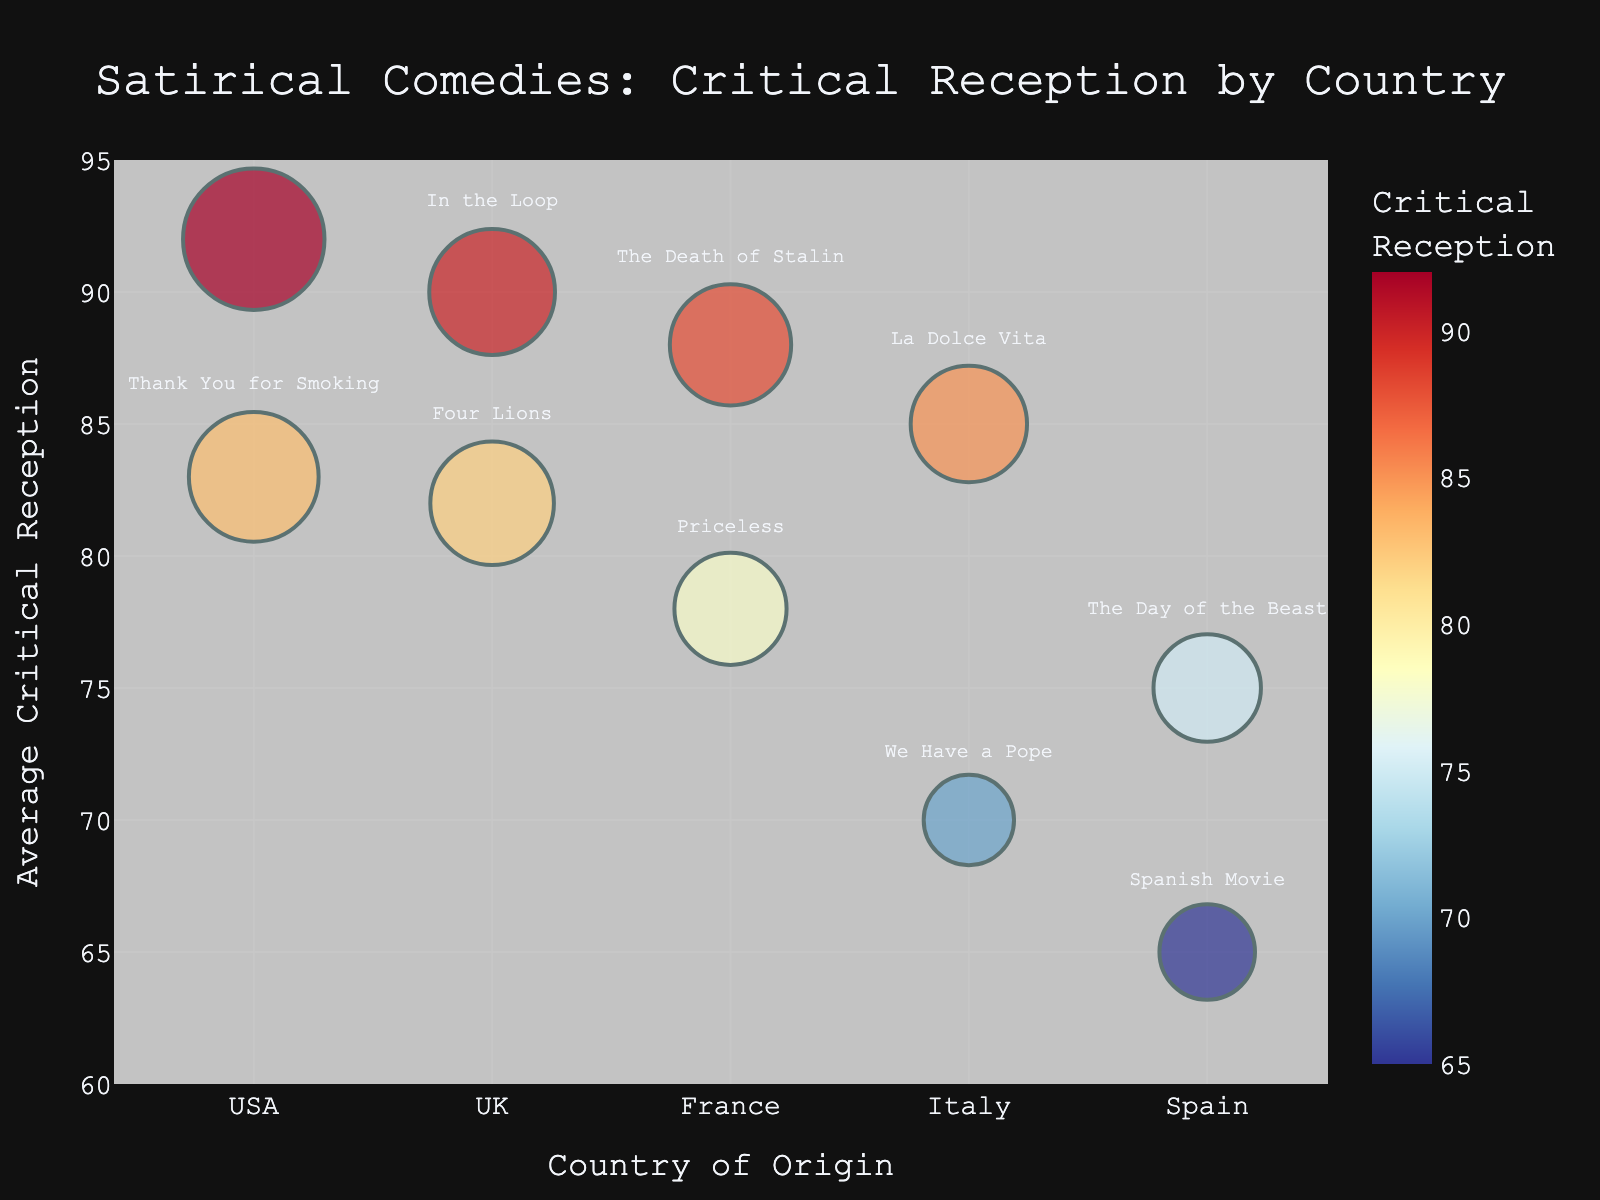Which country has the highest average critical reception for its satirical comedies? The highest average critical reception is indicated by the y-axis value. Dr. Strangelove from the USA has the highest average critical reception of 92.
Answer: USA Which film has the smallest bubble size? The bubble size is proportional to the number of reviews. "We Have a Pope" from Italy has the smallest bubble size, indicating the fewest number of reviews (40).
Answer: We Have a Pope How many countries are represented in the bubble chart? Each unique entry along the x-axis represents a different country. There are five unique countries: USA, UK, France, Italy, and Spain.
Answer: 5 Which film from the UK has the highest critical reception? The highest critical reception for UK films is represented by the highest y-axis value within the UK category. "In the Loop" from the UK has the highest critical reception of 90.
Answer: In the Loop Which film has the most reviews? The bubble with the largest size indicates the film with the most reviews. "Dr. Strangelove" from the USA has the largest bubble with 240 reviews.
Answer: Dr. Strangelove What is the difference in average critical reception between the film with the highest reception and the film with the lowest reception? The highest reception is 92 (Dr. Strangelove) and the lowest is 65 (Spanish Movie). The difference is 92 - 65 = 27.
Answer: 27 Which country has the most films represented in the chart? Count the bubbles for each country. The USA has two films: "Dr. Strangelove" and "Thank You for Smoking", which is the highest number.
Answer: USA Which film has the closest critical reception to 80? Identify the film closest to the y-axis value of 80. "Four Lions" from the UK has an average critical reception of 82, which is the closest to 80.
Answer: Four Lions Are there any films from France with a critical reception above 85? Check the y-axis values for films from France. "The Death of Stalin" has a critical reception of 88, which is above 85.
Answer: Yes How does the critical reception of "La Dolce Vita" compare to the critical reception of "Thank You for Smoking"? Compare the y-axis values of "La Dolce Vita" (85) and "Thank You for Smoking" (83). 85 is greater than 83.
Answer: La Dolce Vita is higher 